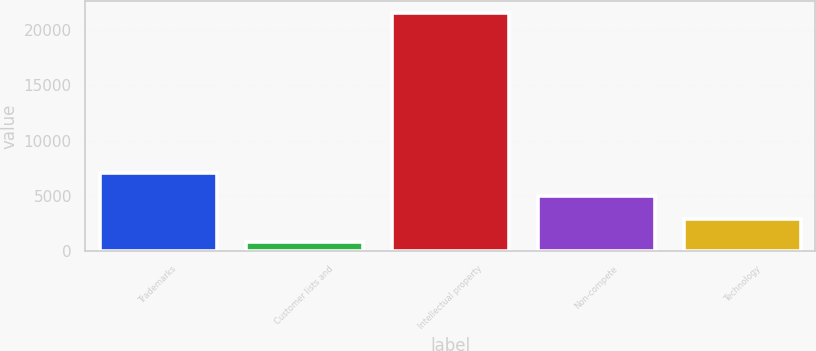Convert chart. <chart><loc_0><loc_0><loc_500><loc_500><bar_chart><fcel>Trademarks<fcel>Customer lists and<fcel>Intellectual property<fcel>Non-compete<fcel>Technology<nl><fcel>7050.2<fcel>842<fcel>21536<fcel>4980.8<fcel>2911.4<nl></chart> 